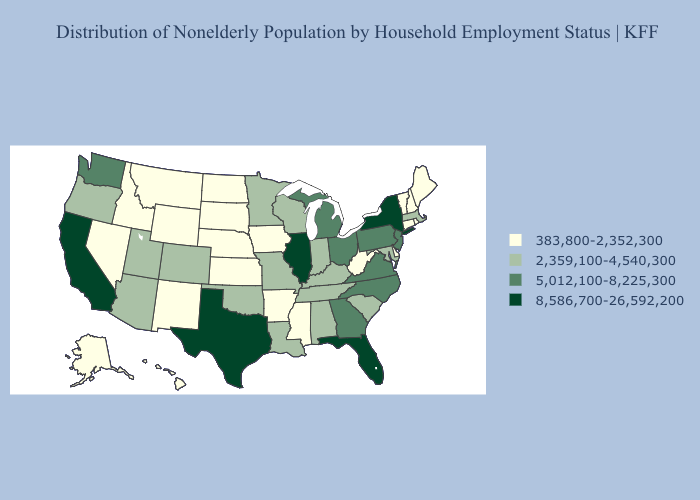What is the value of Idaho?
Answer briefly. 383,800-2,352,300. Does Arizona have a higher value than Oregon?
Short answer required. No. Name the states that have a value in the range 8,586,700-26,592,200?
Answer briefly. California, Florida, Illinois, New York, Texas. Which states have the lowest value in the MidWest?
Concise answer only. Iowa, Kansas, Nebraska, North Dakota, South Dakota. Among the states that border California , which have the highest value?
Short answer required. Arizona, Oregon. What is the lowest value in the MidWest?
Quick response, please. 383,800-2,352,300. Does Wyoming have the lowest value in the West?
Write a very short answer. Yes. What is the value of Wyoming?
Give a very brief answer. 383,800-2,352,300. Does Illinois have the lowest value in the USA?
Keep it brief. No. What is the value of Minnesota?
Be succinct. 2,359,100-4,540,300. How many symbols are there in the legend?
Short answer required. 4. Name the states that have a value in the range 383,800-2,352,300?
Short answer required. Alaska, Arkansas, Connecticut, Delaware, Hawaii, Idaho, Iowa, Kansas, Maine, Mississippi, Montana, Nebraska, Nevada, New Hampshire, New Mexico, North Dakota, Rhode Island, South Dakota, Vermont, West Virginia, Wyoming. Which states have the lowest value in the South?
Keep it brief. Arkansas, Delaware, Mississippi, West Virginia. Does the map have missing data?
Quick response, please. No. Name the states that have a value in the range 2,359,100-4,540,300?
Be succinct. Alabama, Arizona, Colorado, Indiana, Kentucky, Louisiana, Maryland, Massachusetts, Minnesota, Missouri, Oklahoma, Oregon, South Carolina, Tennessee, Utah, Wisconsin. 